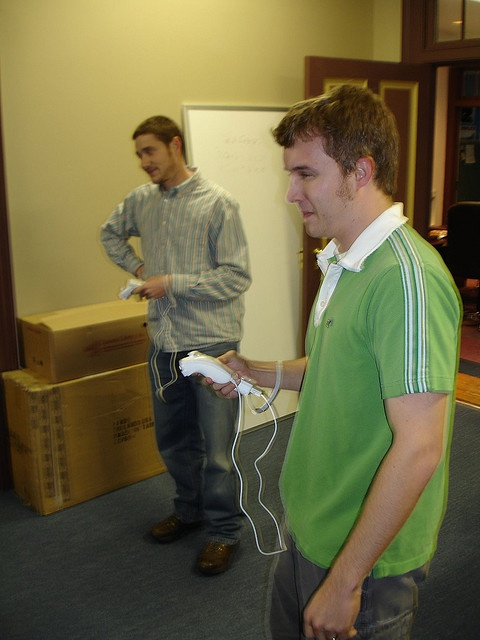Describe the objects in this image and their specific colors. I can see people in olive, green, darkgreen, black, and gray tones, people in olive, black, and gray tones, chair in olive, black, maroon, and brown tones, remote in olive, lightgray, and darkgray tones, and remote in olive, lightgray, tan, darkgray, and beige tones in this image. 